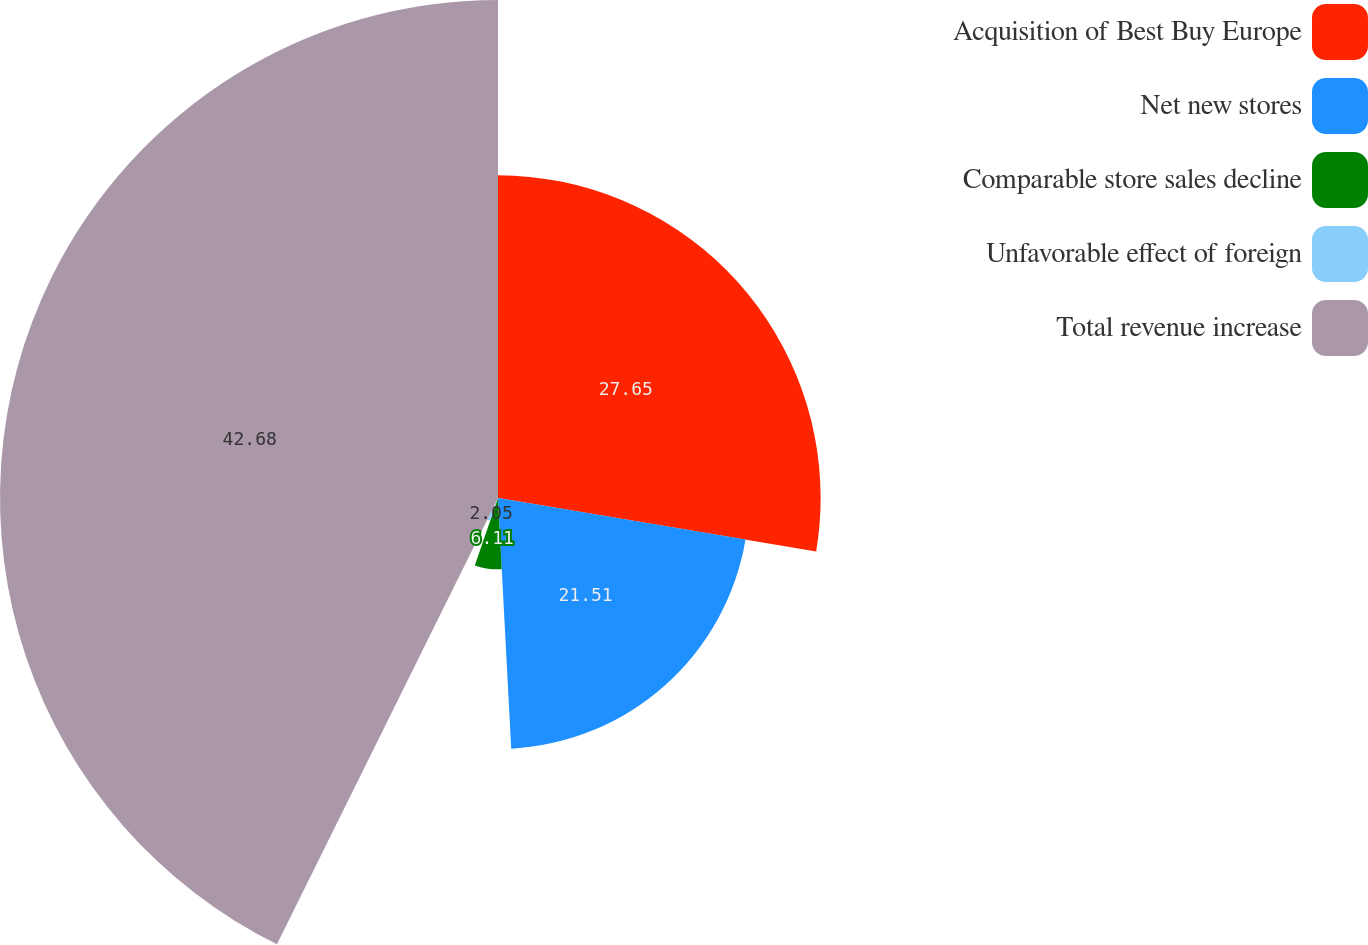Convert chart to OTSL. <chart><loc_0><loc_0><loc_500><loc_500><pie_chart><fcel>Acquisition of Best Buy Europe<fcel>Net new stores<fcel>Comparable store sales decline<fcel>Unfavorable effect of foreign<fcel>Total revenue increase<nl><fcel>27.65%<fcel>21.51%<fcel>6.11%<fcel>2.05%<fcel>42.68%<nl></chart> 